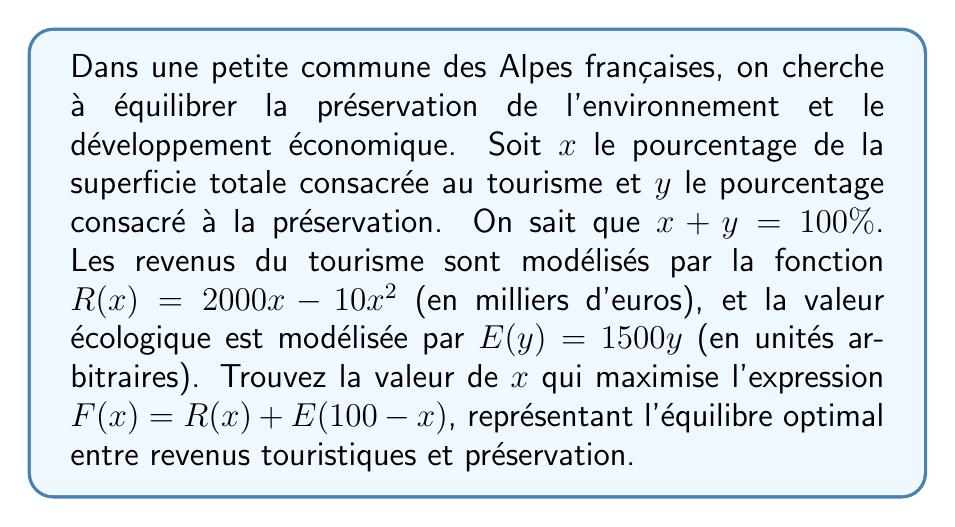Help me with this question. Pour résoudre ce problème, suivons ces étapes :

1) Exprimons $F(x)$ en fonction de $x$ uniquement :
   $F(x) = R(x) + E(100-x)$
   $F(x) = (2000x - 10x^2) + 1500(100-x)$
   $F(x) = 2000x - 10x^2 + 150000 - 1500x$
   $F(x) = -10x^2 + 500x + 150000$

2) Pour trouver le maximum de cette fonction quadratique, nous devons trouver le sommet de la parabole. Le sommet se trouve à $x = -\frac{b}{2a}$ où $a$ et $b$ sont les coefficients de la forme $ax^2 + bx + c$.

3) Dans notre cas, $a = -10$ et $b = 500$. Donc :
   $x = -\frac{500}{2(-10)} = -\frac{500}{-20} = 25$

4) Vérifions que c'est bien un maximum en calculant la dérivée seconde :
   $F'(x) = -20x + 500$
   $F''(x) = -20$
   Comme $F''(x)$ est négative, nous avons bien un maximum.

5) Vérifions que cette solution est dans l'intervalle valide [0, 100] :
   $0 \leq 25 \leq 100$, donc la solution est valide.

Ainsi, l'équilibre optimal est atteint lorsque 25% de la superficie est consacrée au tourisme et, par conséquent, 75% à la préservation.
Answer: $x = 25\%$ 